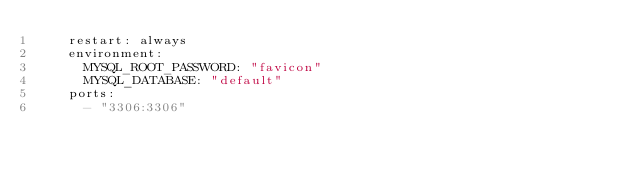<code> <loc_0><loc_0><loc_500><loc_500><_YAML_>    restart: always
    environment:
      MYSQL_ROOT_PASSWORD: "favicon"
      MYSQL_DATABASE: "default"
    ports:
      - "3306:3306"</code> 